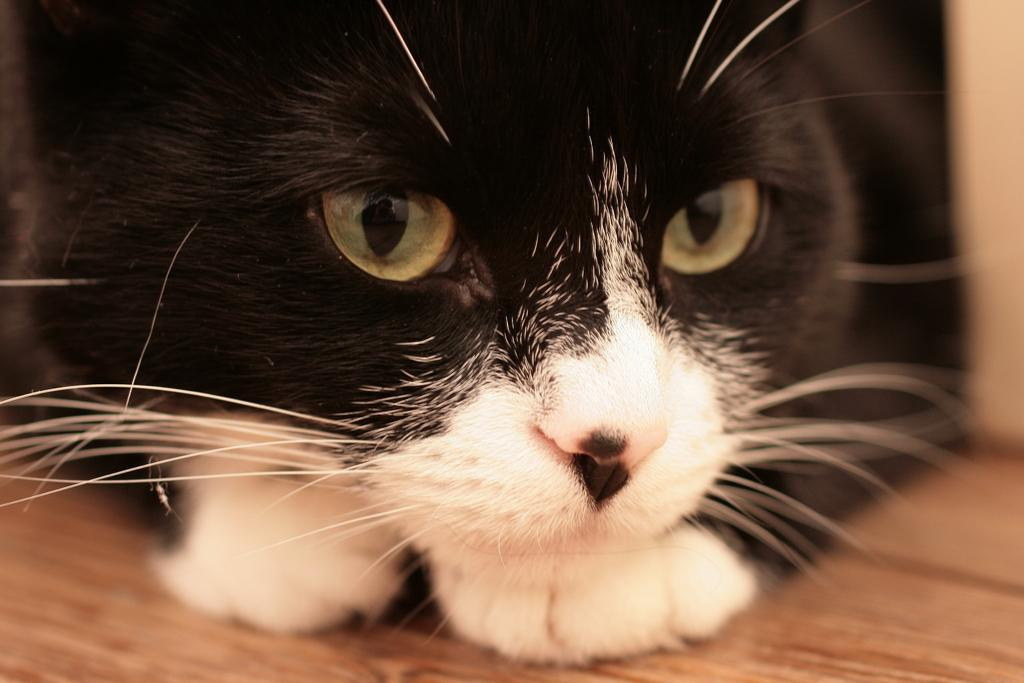What type of animal is in the image? There is a cat in the image. What colors can be seen on the cat? The cat is black and white in color. What type of surface is the cat resting on? The cat is on a wooden surface. What type of scarf is the cat wearing in the image? There is no scarf present in the image; the cat is not wearing any clothing. 